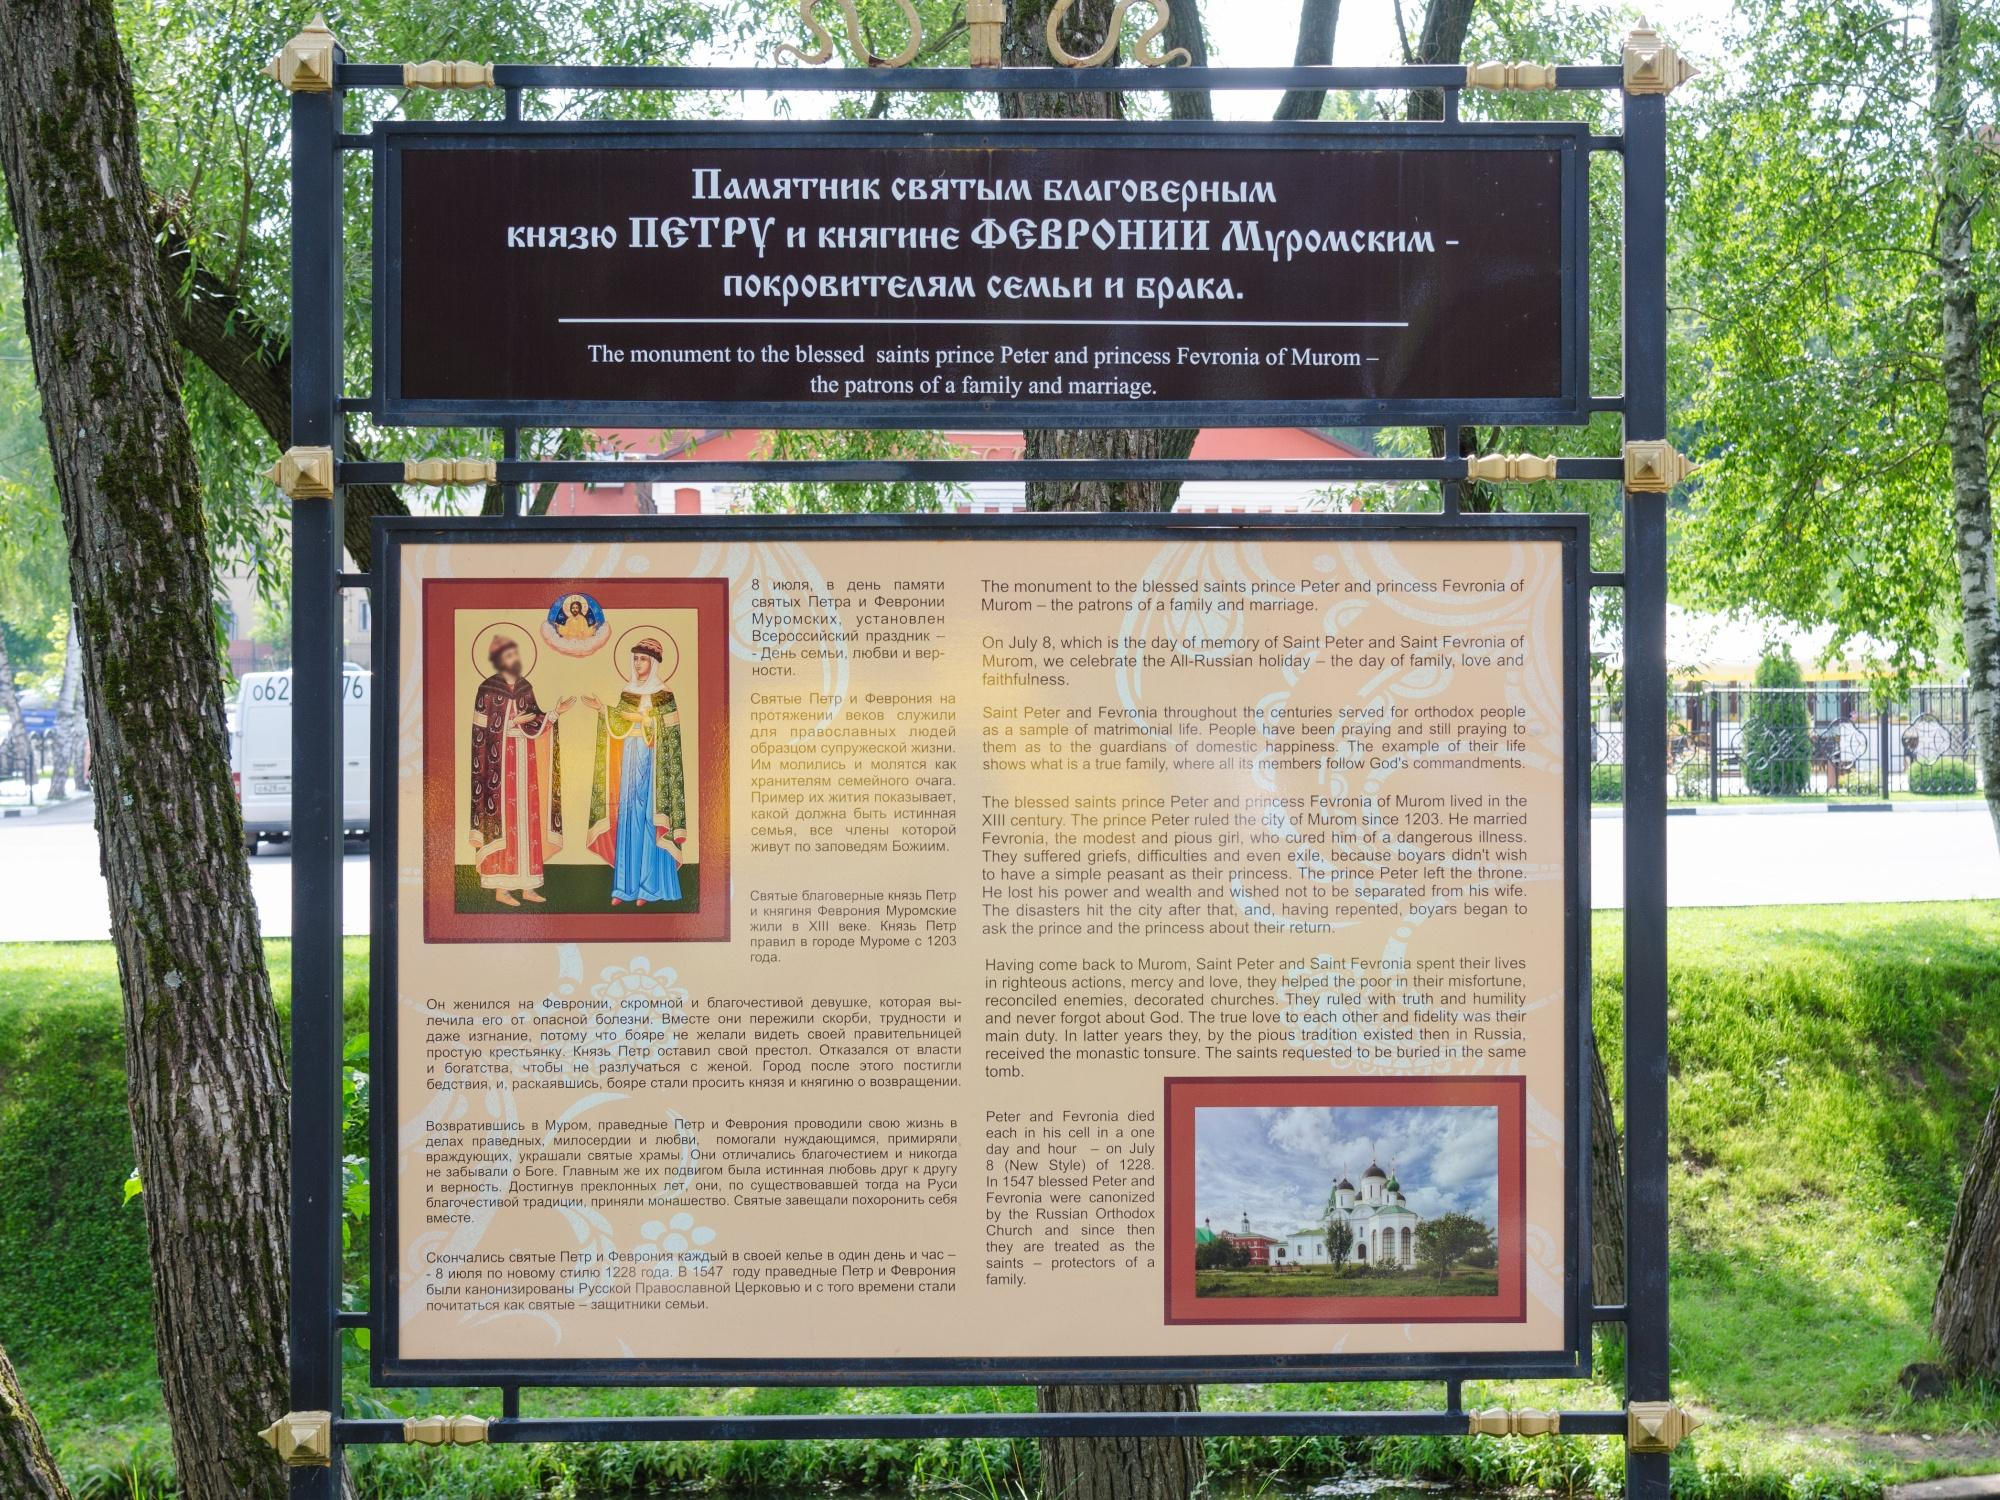What details can you provide about the design of the signboard and its integration into the park environment? The signboard is thoughtfully designed with a classic aesthetic that harmonizes with the serene park surroundings. Mounted on two sturdy wooden poles, it features a sleek black border, ensuring readability. The background is a clean white, which effectively contrasts with the colorful depictions and Cyrillic text, drawing the viewer's eye and facilitating easy reading. Its placement under the shade of green trees not only protects it from direct sunlight but also integrates it naturally into the calm park ambiance, making it a welcoming spot for visitors to gather and learn. 